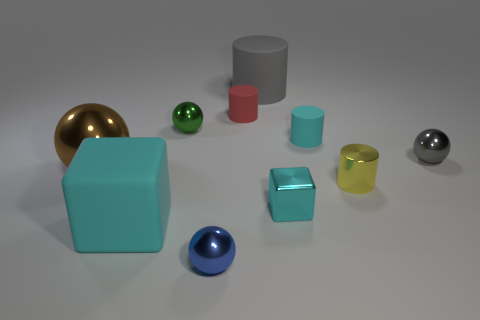Do the small gray sphere and the small red cylinder have the same material? The small gray sphere appears to have a metallic sheen, while the small red cylinder lacks this sheen and seems to have a more matte finish, which suggests that they are made of different materials. 